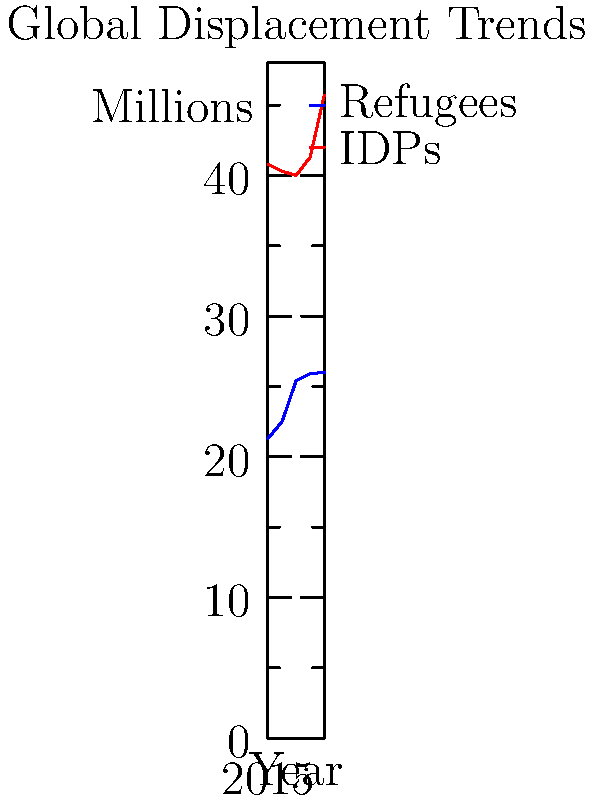Based on the infographic showing global displacement trends from 2015 to 2019, what was the difference between the number of Internally Displaced Persons (IDPs) and refugees in 2019? To find the difference between IDPs and refugees in 2019, we need to:

1. Identify the number of IDPs in 2019:
   From the red line (IDPs), we can see that in 2019, there were 45.7 million IDPs.

2. Identify the number of refugees in 2019:
   From the blue line (Refugees), we can see that in 2019, there were 26.0 million refugees.

3. Calculate the difference:
   $45.7 - 26.0 = 19.7$ million

Therefore, the difference between IDPs and refugees in 2019 was 19.7 million.
Answer: 19.7 million 